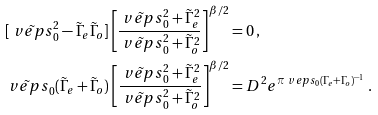<formula> <loc_0><loc_0><loc_500><loc_500>& [ \tilde { \ v e p s } _ { 0 } ^ { 2 } - \tilde { \Gamma } _ { e } \tilde { \Gamma } _ { o } ] \left [ \frac { \tilde { \ v e p s } _ { 0 } ^ { 2 } + \tilde { \Gamma } _ { e } ^ { 2 } } { \tilde { \ v e p s } _ { 0 } ^ { 2 } + \tilde { \Gamma } _ { o } ^ { 2 } } \right ] ^ { \beta / 2 } = 0 \, , \\ & \tilde { \ v e p s } _ { 0 } ( \tilde { \Gamma } _ { e } + \tilde { \Gamma } _ { o } ) \left [ \frac { \tilde { \ v e p s } _ { 0 } ^ { 2 } + \tilde { \Gamma } _ { e } ^ { 2 } } { \tilde { \ v e p s } _ { 0 } ^ { 2 } + \tilde { \Gamma } _ { o } ^ { 2 } } \right ] ^ { \beta / 2 } = D ^ { 2 } e ^ { \pi \ v e p s _ { 0 } ( \Gamma _ { e } + \Gamma _ { o } ) ^ { - 1 } } \, .</formula> 